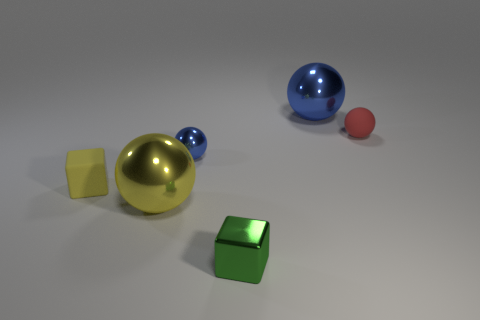What material characteristics can be inferred about the objects? Based on the way light interacts with the surfaces, the golden sphere and blue sphere appear to have shiny, reflective qualities. The yellow and green cubes seem to have a matte texture, and the red sphere looks like it has a smooth but non-reflective surface. 